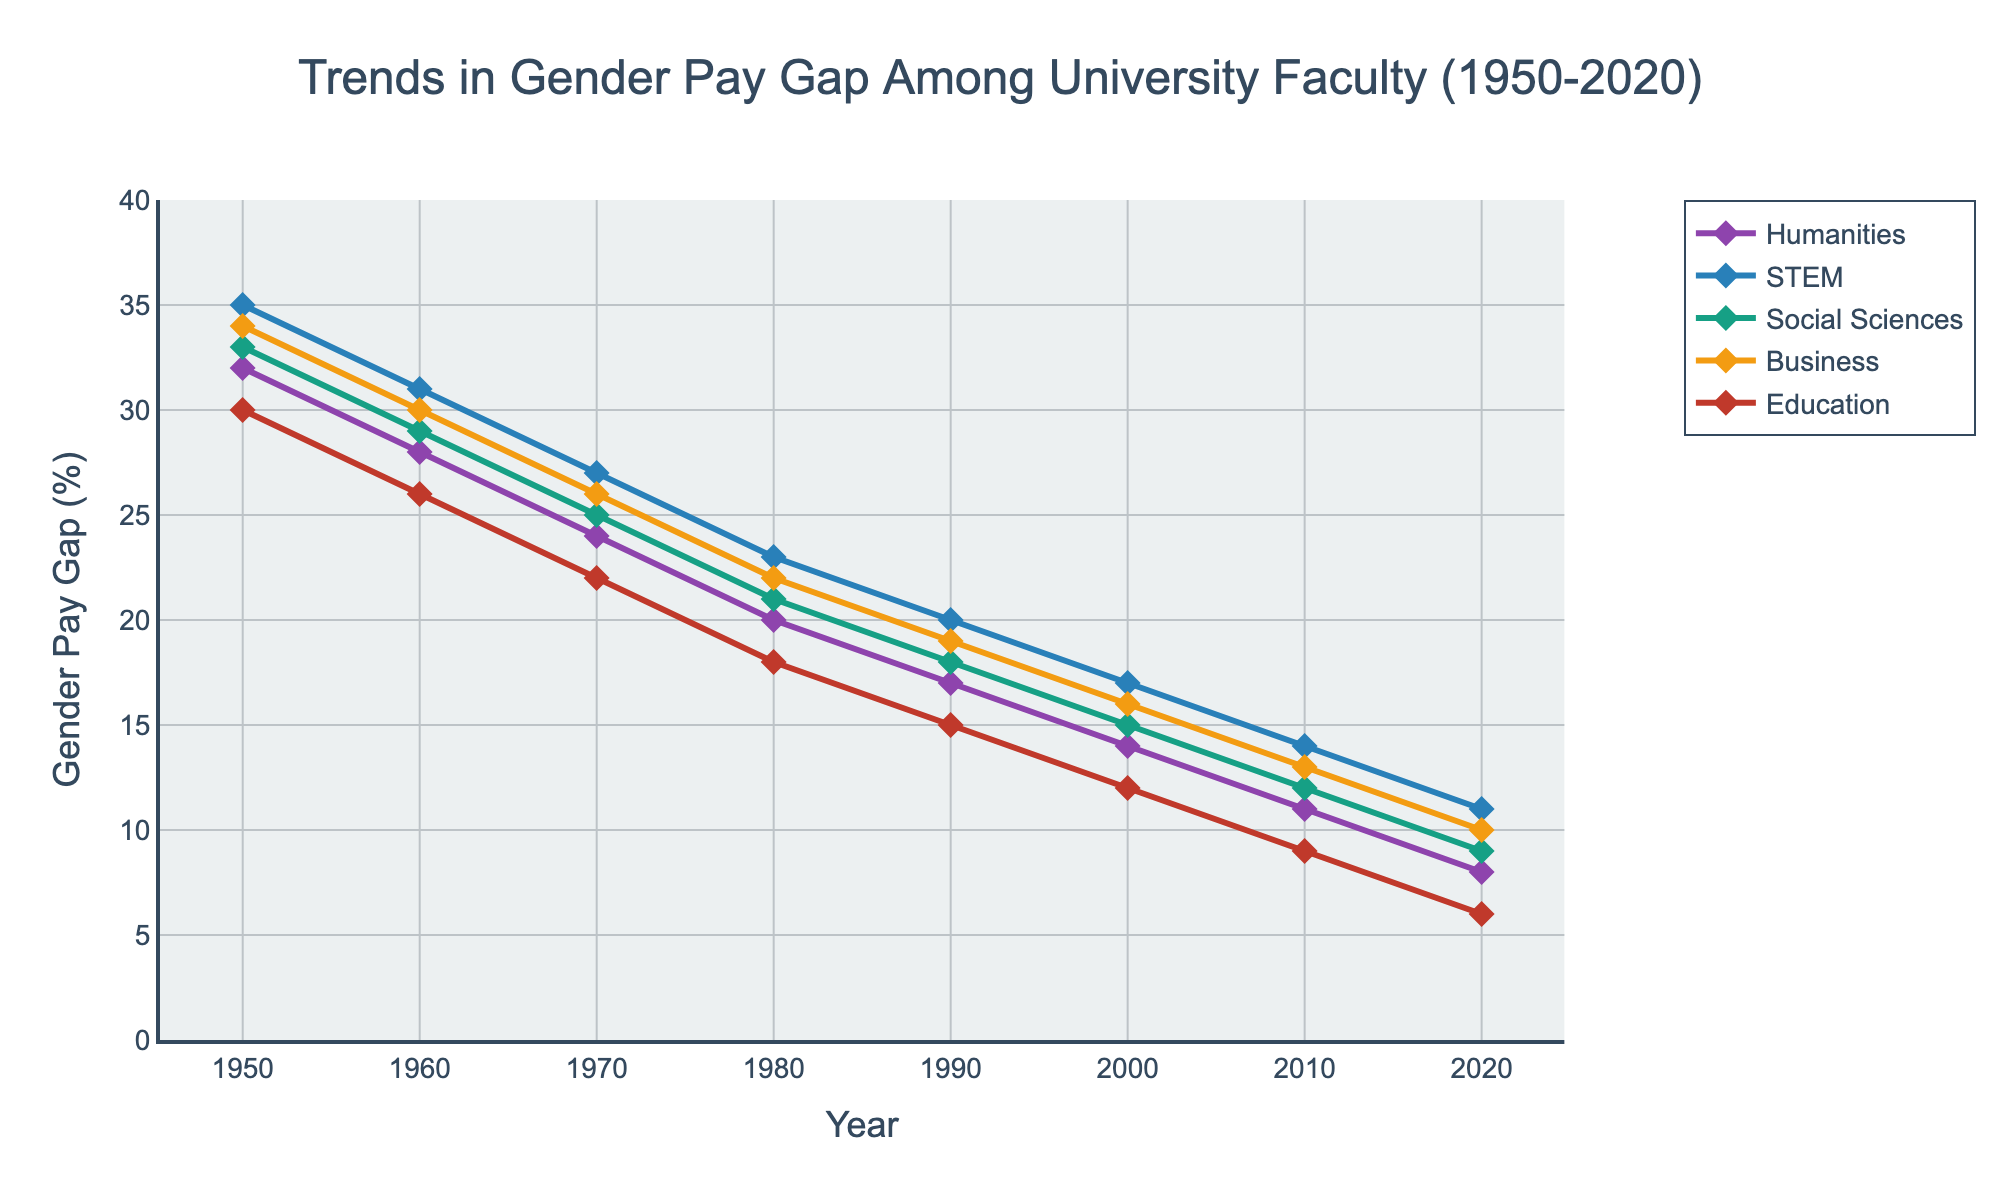what is the trend in the gender pay gap for Humanities from 1950 to 2020? The trend can be observed by looking at the plot line for Humanities. In 1950, it starts at 32% and continuously decreases over the years, reaching 8% by 2020. This indicates a consistent decline over the period.
Answer: The gender pay gap decreased from 32% in 1950 to 8% in 2020 In which year did the gender pay gap in STEM reach 20%? Observing the plot, the line representing STEM touches the 20% mark around 1990.
Answer: 1990 Which discipline had the smallest gender pay gap in 2000? By comparing the points for each discipline in 2000, Education shows the smallest gap at 12%.
Answer: Education How does the gender pay gap in Business in 1980 compare to that in Education in 1960? In 1980, the gender pay gap in Business is at 22%, whereas in Education in 1960, it is 26%. By comparing the two values, Business had a smaller gap in 1980 than Education did in 1960.
Answer: Business in 1980 had a smaller pay gap By how much did the gender pay gap in Social Sciences decrease from 1950 to 1970? In 1950, the gap is 33%. By 1970, it decreased to 25%. The change can be calculated as 33% - 25% = 8%.
Answer: 8% Which discipline shows the fastest decline in the gender pay gap from 1950 to 2020? To find this, observe the initial and final values for each discipline. Education declines from 30% in 1950 to 6% in 2020, a decrease of 24%. Other disciplines show smaller total declines.
Answer: Education Around what year did the gender pay gap in Humanities reach below 10%? Checking the Humanities plot line, it drops below 10% around 2010.
Answer: Around 2010 What is the average gender pay gap in Social Sciences over the years 1950, 1970, and 1990? Take the values for Social Sciences in 1950 (33%), 1970 (25%), and 1990 (18%). The average is (33 + 25 + 18) / 3 = 76 / 3 = 25.33%.
Answer: 25.33% Compare the trends in gender pay gap for STEM and Business from 1980 to 2020. Both disciplines show a decreasing trend. Starting from 1980, STEM reduces from 23% to 11%, while Business declines from 22% to 10%. The overall trends are both downward.
Answer: Both disciplines show a decreasing trend 